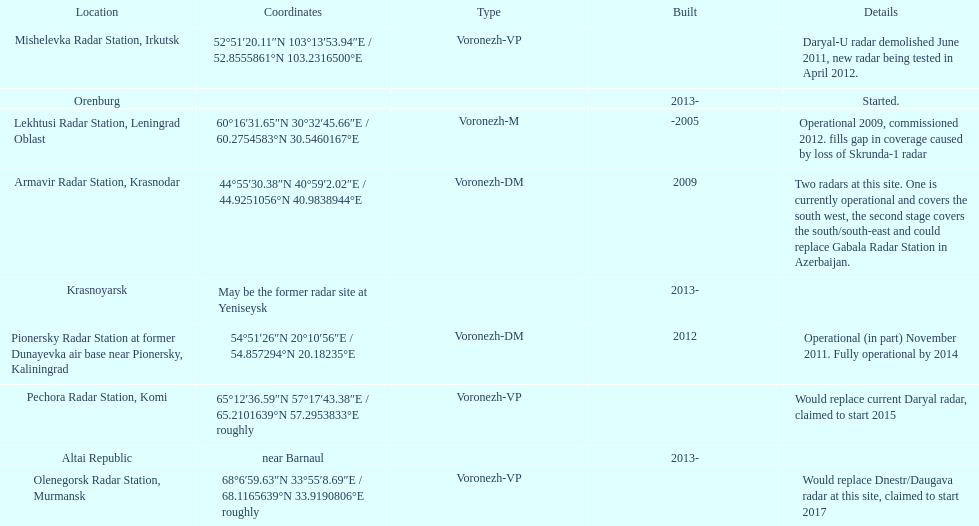Which site has the most radars? Armavir Radar Station, Krasnodar. 